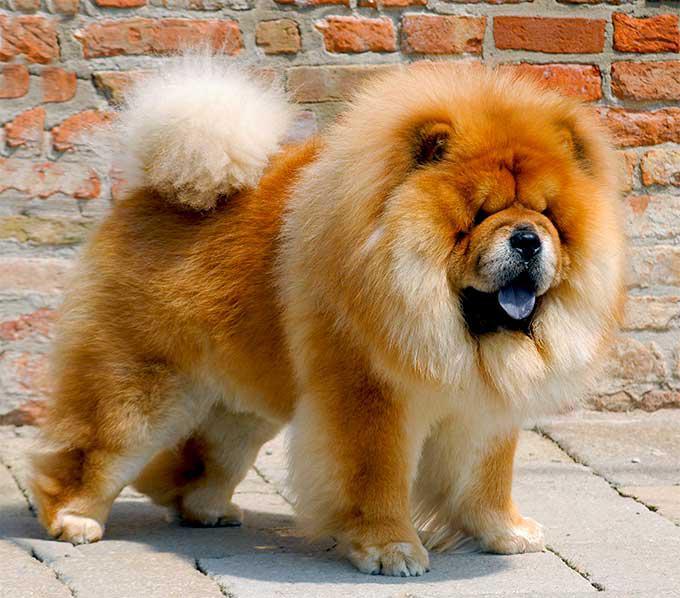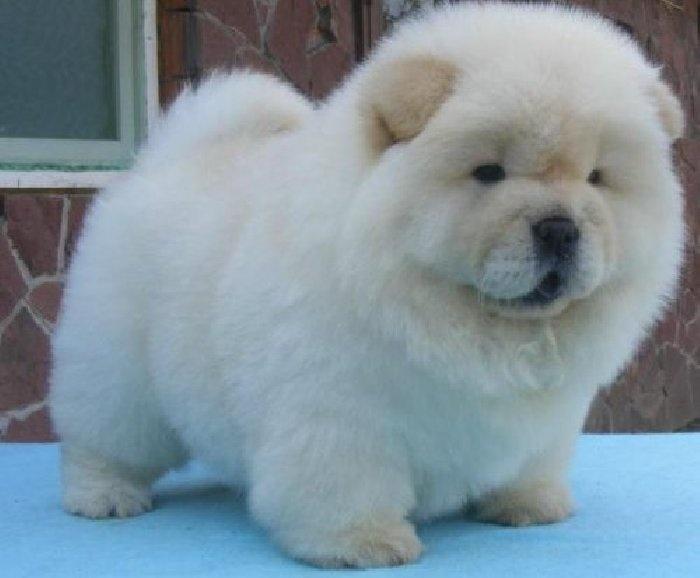The first image is the image on the left, the second image is the image on the right. Considering the images on both sides, is "a brick wall is behind a dog." valid? Answer yes or no. Yes. 